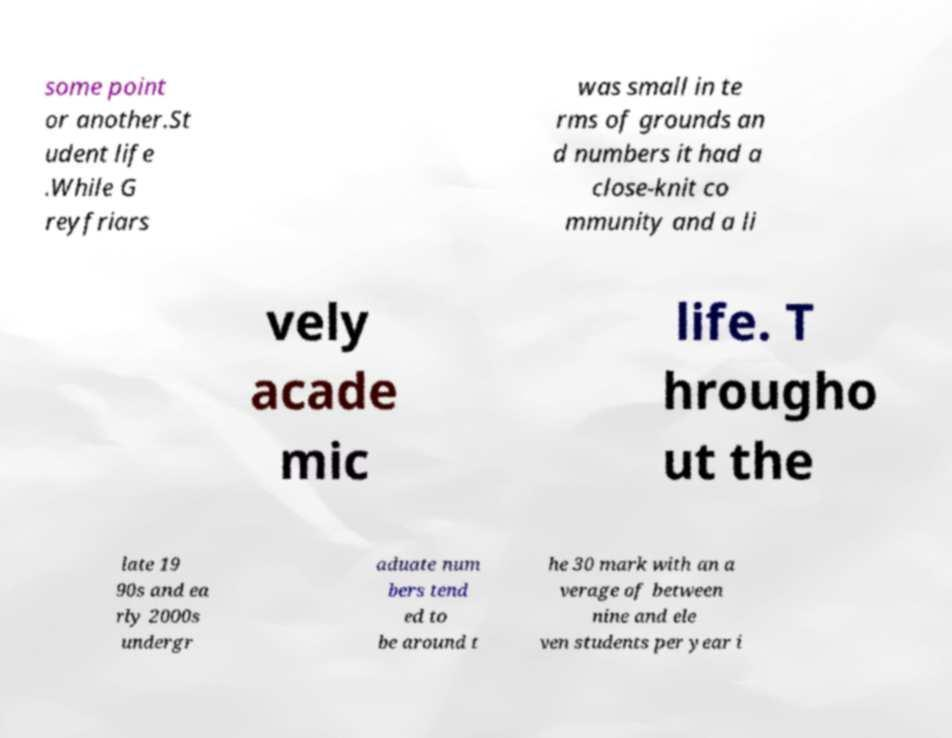What messages or text are displayed in this image? I need them in a readable, typed format. some point or another.St udent life .While G reyfriars was small in te rms of grounds an d numbers it had a close-knit co mmunity and a li vely acade mic life. T hrougho ut the late 19 90s and ea rly 2000s undergr aduate num bers tend ed to be around t he 30 mark with an a verage of between nine and ele ven students per year i 